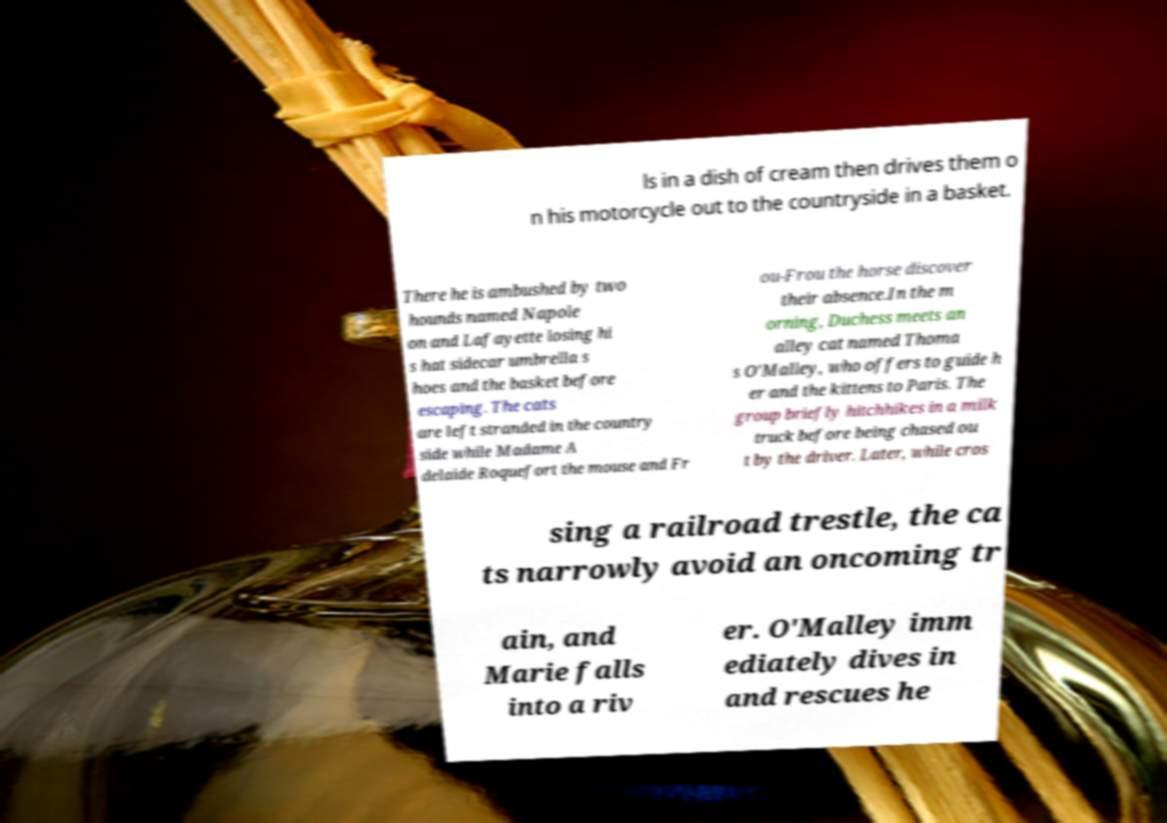Could you extract and type out the text from this image? ls in a dish of cream then drives them o n his motorcycle out to the countryside in a basket. There he is ambushed by two hounds named Napole on and Lafayette losing hi s hat sidecar umbrella s hoes and the basket before escaping. The cats are left stranded in the country side while Madame A delaide Roquefort the mouse and Fr ou-Frou the horse discover their absence.In the m orning, Duchess meets an alley cat named Thoma s O'Malley, who offers to guide h er and the kittens to Paris. The group briefly hitchhikes in a milk truck before being chased ou t by the driver. Later, while cros sing a railroad trestle, the ca ts narrowly avoid an oncoming tr ain, and Marie falls into a riv er. O'Malley imm ediately dives in and rescues he 